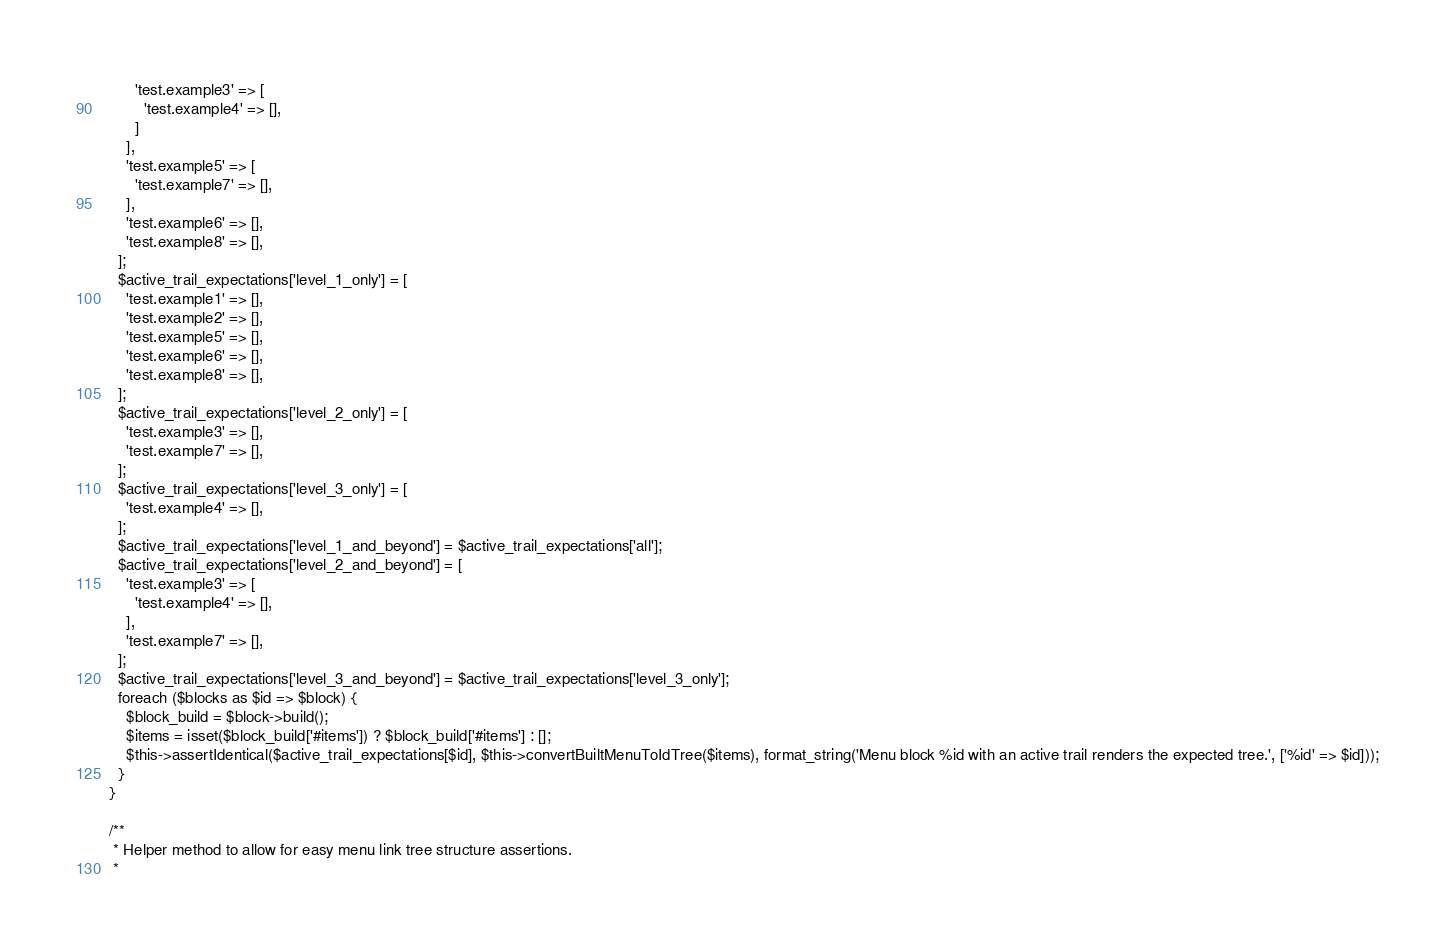<code> <loc_0><loc_0><loc_500><loc_500><_PHP_>        'test.example3' => [
          'test.example4' => [],
        ]
      ],
      'test.example5' => [
        'test.example7' => [],
      ],
      'test.example6' => [],
      'test.example8' => [],
    ];
    $active_trail_expectations['level_1_only'] = [
      'test.example1' => [],
      'test.example2' => [],
      'test.example5' => [],
      'test.example6' => [],
      'test.example8' => [],
    ];
    $active_trail_expectations['level_2_only'] = [
      'test.example3' => [],
      'test.example7' => [],
    ];
    $active_trail_expectations['level_3_only'] = [
      'test.example4' => [],
    ];
    $active_trail_expectations['level_1_and_beyond'] = $active_trail_expectations['all'];
    $active_trail_expectations['level_2_and_beyond'] = [
      'test.example3' => [
        'test.example4' => [],
      ],
      'test.example7' => [],
    ];
    $active_trail_expectations['level_3_and_beyond'] = $active_trail_expectations['level_3_only'];
    foreach ($blocks as $id => $block) {
      $block_build = $block->build();
      $items = isset($block_build['#items']) ? $block_build['#items'] : [];
      $this->assertIdentical($active_trail_expectations[$id], $this->convertBuiltMenuToIdTree($items), format_string('Menu block %id with an active trail renders the expected tree.', ['%id' => $id]));
    }
  }

  /**
   * Helper method to allow for easy menu link tree structure assertions.
   *</code> 